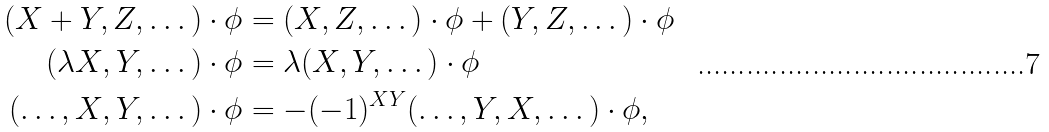<formula> <loc_0><loc_0><loc_500><loc_500>( X + Y , Z , \dots ) \cdot \phi & = ( X , Z , \dots ) \cdot \phi + ( Y , Z , \dots ) \cdot \phi \\ ( \lambda X , Y , \dots ) \cdot \phi & = \lambda ( X , Y , \dots ) \cdot \phi \\ ( \dots , X , Y , \dots ) \cdot \phi & = - ( - 1 ) ^ { X Y } ( \dots , Y , X , \dots ) \cdot \phi ,</formula> 